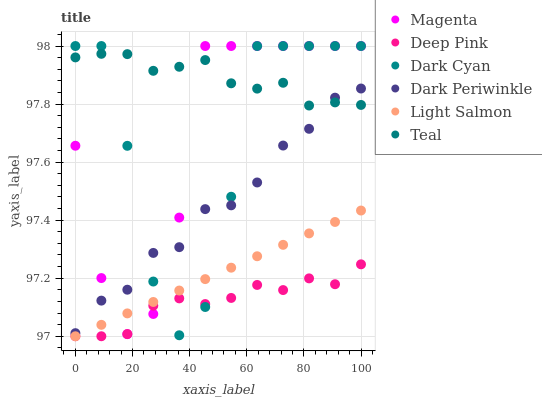Does Deep Pink have the minimum area under the curve?
Answer yes or no. Yes. Does Teal have the maximum area under the curve?
Answer yes or no. Yes. Does Teal have the minimum area under the curve?
Answer yes or no. No. Does Deep Pink have the maximum area under the curve?
Answer yes or no. No. Is Light Salmon the smoothest?
Answer yes or no. Yes. Is Dark Cyan the roughest?
Answer yes or no. Yes. Is Deep Pink the smoothest?
Answer yes or no. No. Is Deep Pink the roughest?
Answer yes or no. No. Does Light Salmon have the lowest value?
Answer yes or no. Yes. Does Teal have the lowest value?
Answer yes or no. No. Does Magenta have the highest value?
Answer yes or no. Yes. Does Teal have the highest value?
Answer yes or no. No. Is Light Salmon less than Teal?
Answer yes or no. Yes. Is Dark Periwinkle greater than Light Salmon?
Answer yes or no. Yes. Does Magenta intersect Teal?
Answer yes or no. Yes. Is Magenta less than Teal?
Answer yes or no. No. Is Magenta greater than Teal?
Answer yes or no. No. Does Light Salmon intersect Teal?
Answer yes or no. No. 